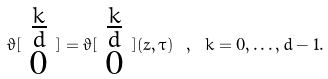<formula> <loc_0><loc_0><loc_500><loc_500>\vartheta [ \begin{array} { c } { { \frac { k } { d } } } \\ { 0 } \end{array} ] = \vartheta [ \begin{array} { c } { { \frac { k } { d } } } \\ { 0 } \end{array} ] ( z , \tau ) \ , \ k = 0 , \dots , d - 1 .</formula> 